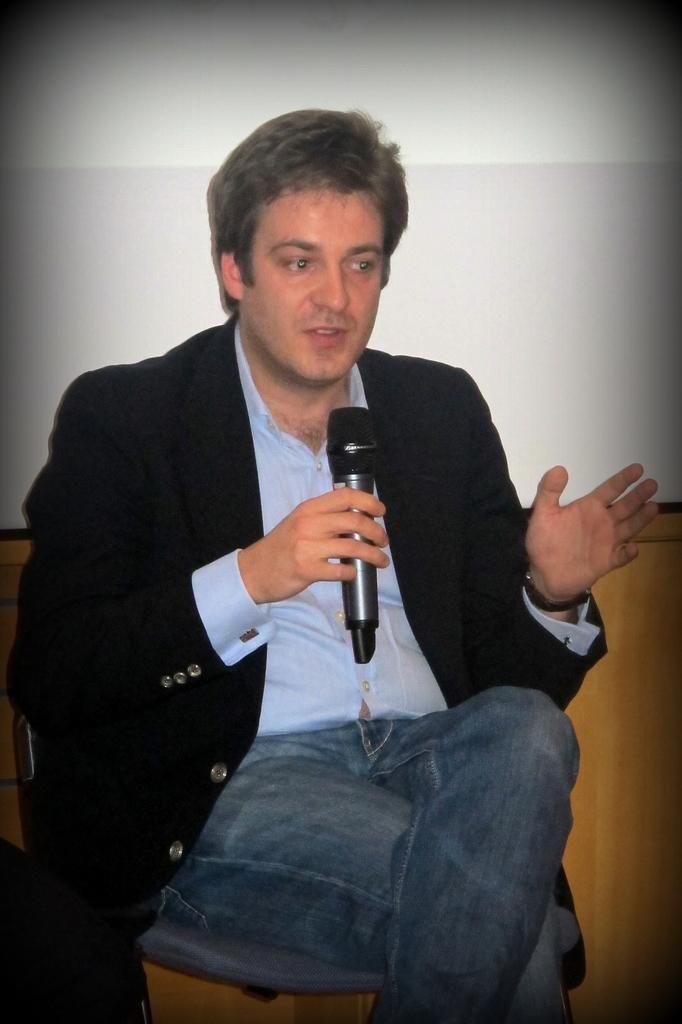Please provide a concise description of this image. In this picture we can see a man who is sitting on the chair. And he hold a mike with his hand. On the background there is a wall. 